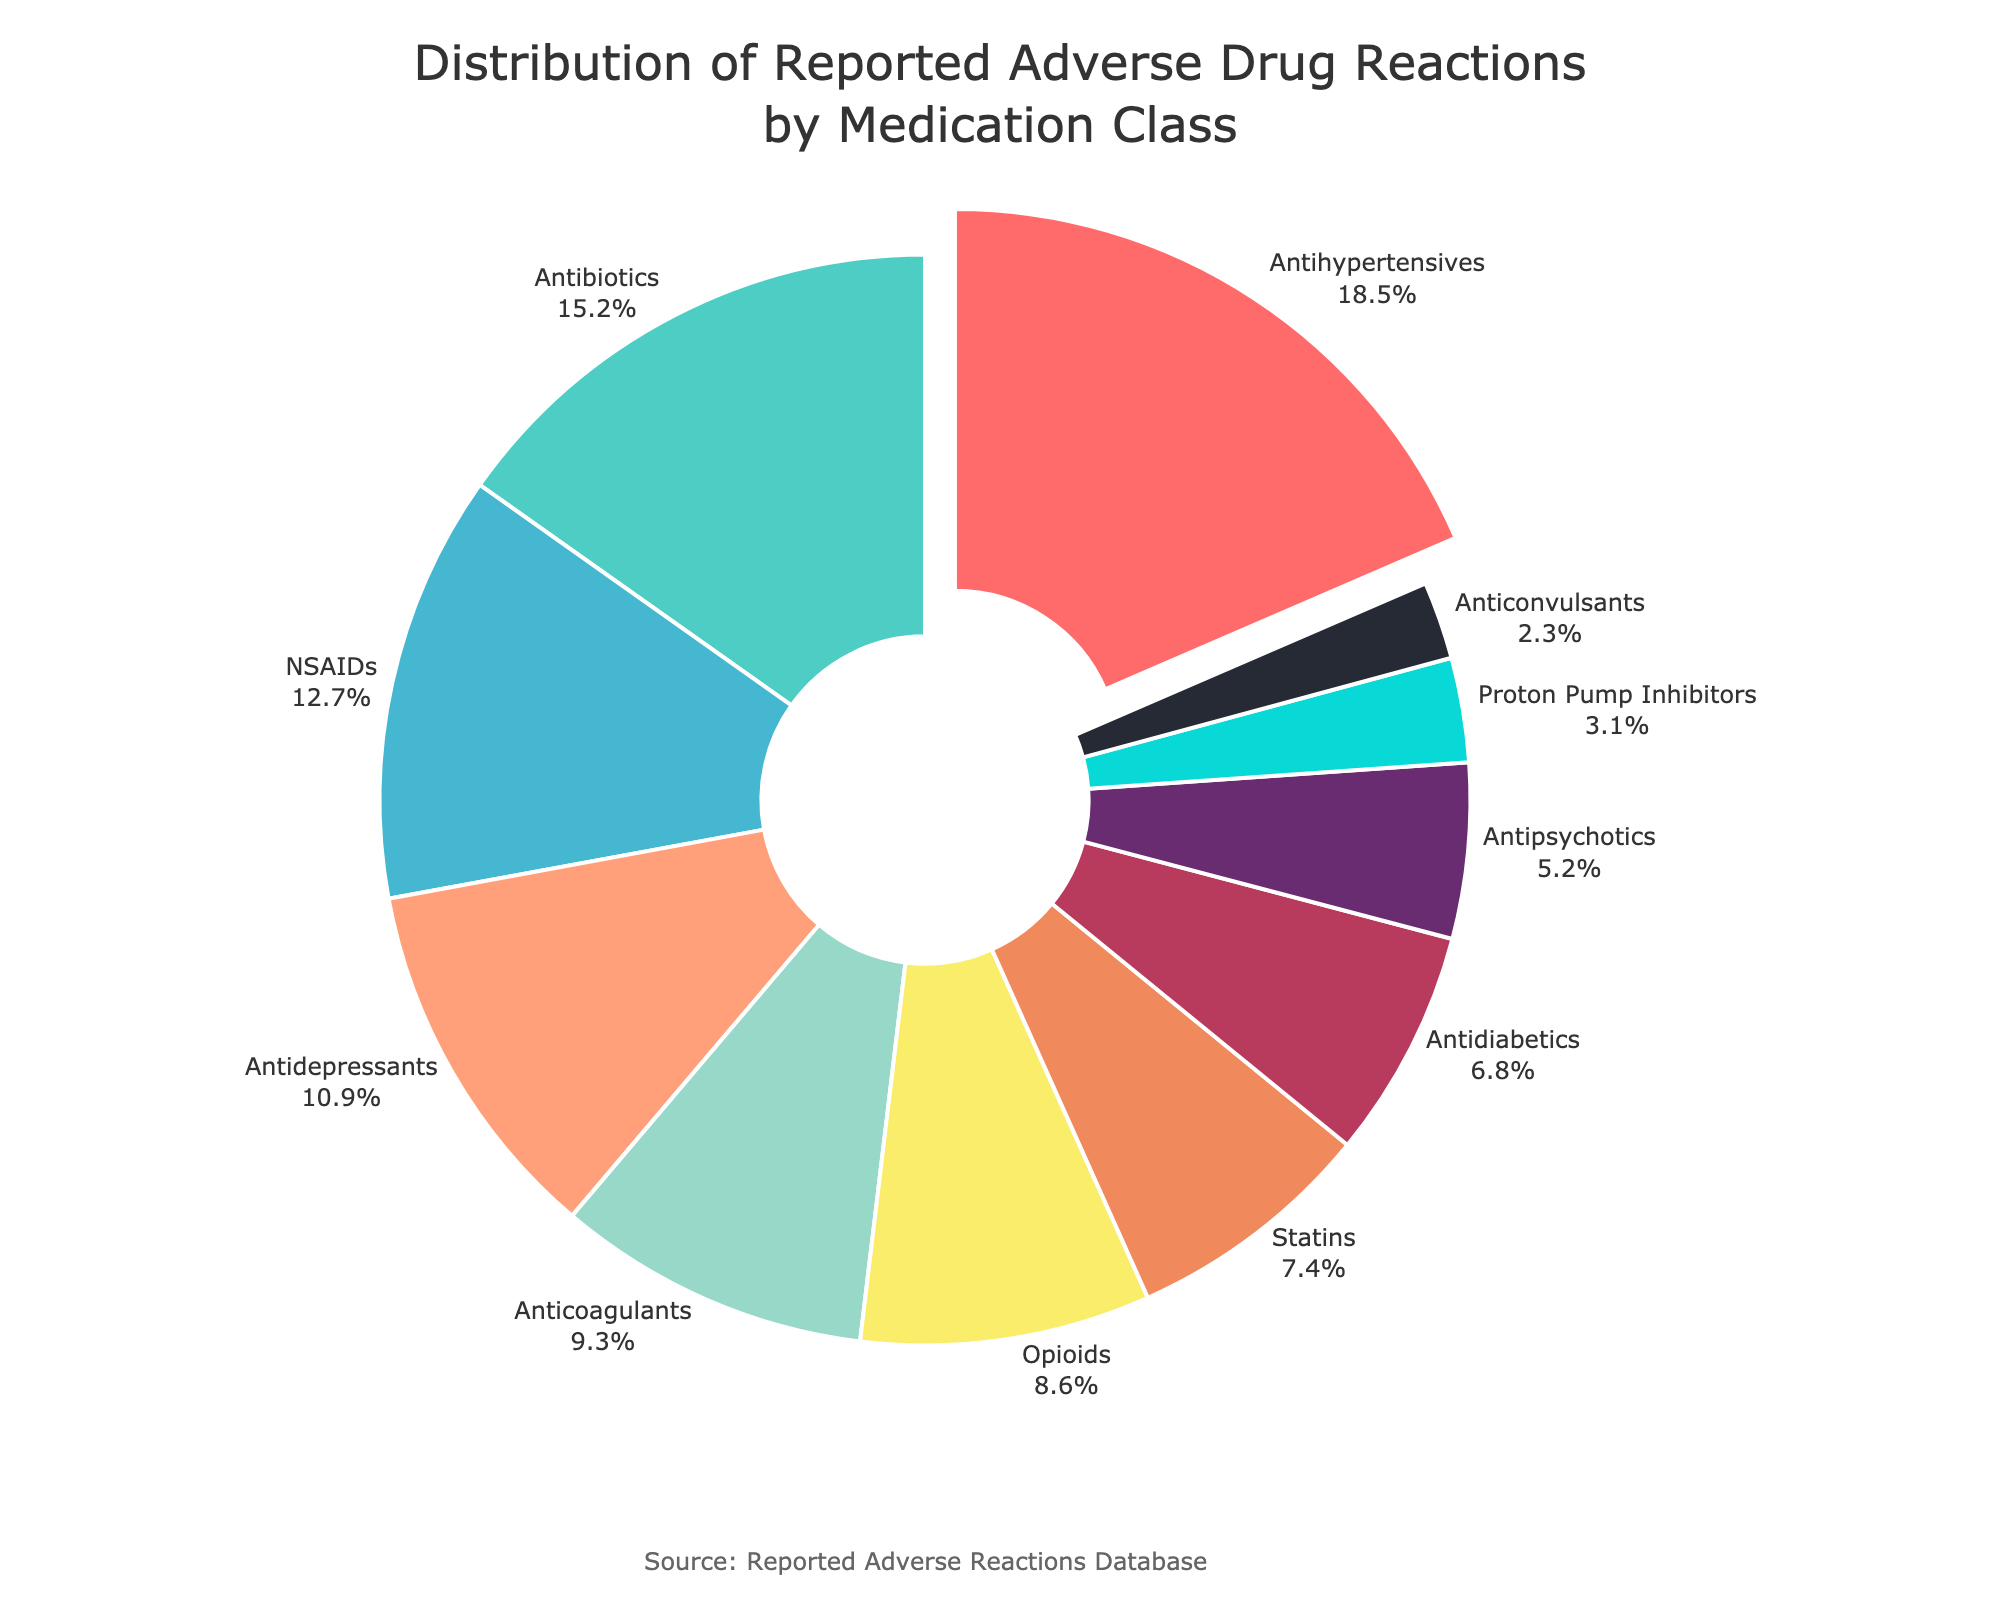What medication class has the highest percentage of reported adverse reactions? The pie chart highlights the medication class with the highest percentage by slightly pulling it out from the rest. According to the data, Antihypertensives have the highest percentage of reported adverse reactions at 18.5%.
Answer: Antihypertensives How do the percentages of adverse reactions for Antidepressants and Antipsychotics compare? The pie chart shows that 10.9% of reported adverse reactions are due to Antidepressants and 5.2% are due to Antipsychotics. Therefore, the percentage for Antidepressants is roughly double that of Antipsychotics.
Answer: Antidepressants have a higher percentage What is the total percentage of reported adverse reactions for Antibiotics, NSAIDs, and Opioids combined? To find the total percentage, sum the individual percentages of each medication class. For Antibiotics, NSAIDs, and Opioids, the percentages are 15.2%, 12.7%, and 8.6% respectively. Summing these values: 15.2 + 12.7 + 8.6 = 36.5%.
Answer: 36.5% Which medication class has a slightly higher reported adverse reaction rate: Anticoagulants or Statins? The pie chart shows Anticoagulants at 9.3% and Statins at 7.4%. 9.3% is slightly higher than 7.4%, so Anticoagulants have a higher reported adverse reaction rate.
Answer: Anticoagulants By how much does the percentage of reported adverse reactions from Proton Pump Inhibitors differ from that of Antidiabetics? The pie chart displays 3.1% for Proton Pump Inhibitors and 6.8% for Antidiabetics. The difference can be calculated as 6.8 - 3.1 = 3.7%.
Answer: 3.7% What is the combined percentage of reported adverse reactions from Antipsychotics and Anticonvulsants? The pie chart specifies the percentages for Antipsychotics and Anticonvulsants as 5.2% and 2.3%, respectively. Adding these together results in 5.2 + 2.3 = 7.5%.
Answer: 7.5% If you combine the reported adverse reactions for the top three medication classes, what overall percentage do you get? The top three medication classes by percentage are Antihypertensives (18.5%), Antibiotics (15.2%), and NSAIDs (12.7%). Adding these together, the total is 18.5 + 15.2 + 12.7 = 46.4%.
Answer: 46.4% Which medication class has the least reported adverse reactions, and what is the percentage? The pie chart shows that Anticonvulsants have the least reported adverse reactions, marked at 2.3%.
Answer: Anticonvulsants at 2.3% 